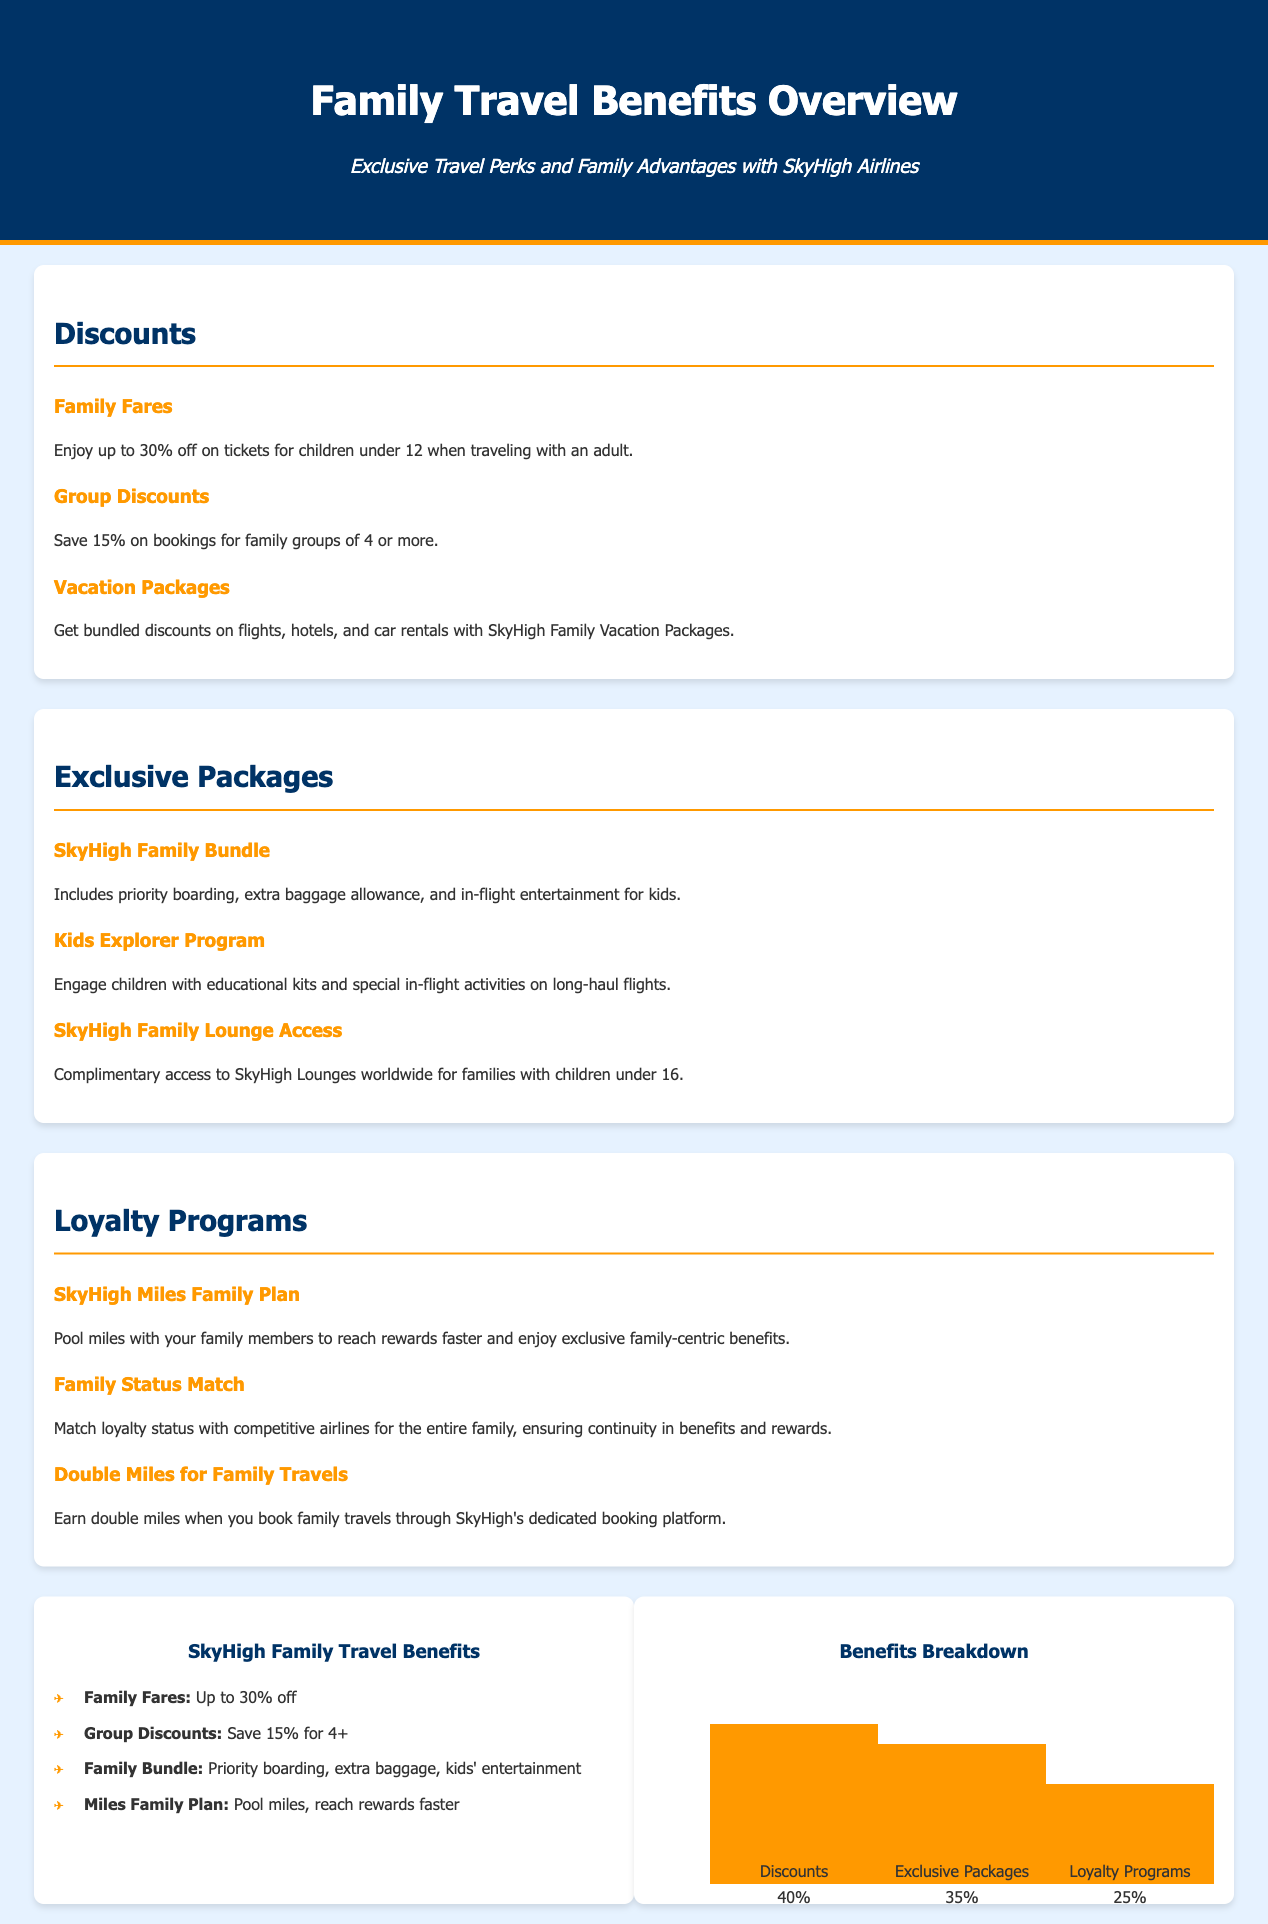What discount do children under 12 receive when traveling with an adult? The document states that children under 12 enjoy up to 30% off on tickets when traveling with an adult.
Answer: 30% off What is the savings percentage for group bookings of 4 or more? The document mentions that families booking for 4 or more can save 15%.
Answer: 15% What is included in the SkyHigh Family Bundle? The document lists priority boarding, extra baggage allowance, and in-flight entertainment for kids as included in the SkyHigh Family Bundle.
Answer: Priority boarding, extra baggage allowance, in-flight entertainment for kids What program provides educational kits and special activities for children? The Kids Explorer Program is designed to engage children with educational kits and special in-flight activities.
Answer: Kids Explorer Program What percentage of the benefits is related to discounts? The chart in the document indicates that discounts account for 40% of the benefits breakdown.
Answer: 40% Which loyalty program allows families to pool miles? The SkyHigh Miles Family Plan allows family members to pool miles together.
Answer: SkyHigh Miles Family Plan What is the height percentage of benefits related to exclusive packages in the chart? The chart shows that exclusive packages make up 35% of the benefits breakdown.
Answer: 35% What age do children need to be under to receive complimentary access to SkyHigh Lounges? The document specifies that families with children under 16 get complimentary access to the lounges.
Answer: Under 16 What is the total height percentage for loyalty programs reflected in the chart? The chart reflects that loyalty programs account for 25% of the benefits breakdown.
Answer: 25% 